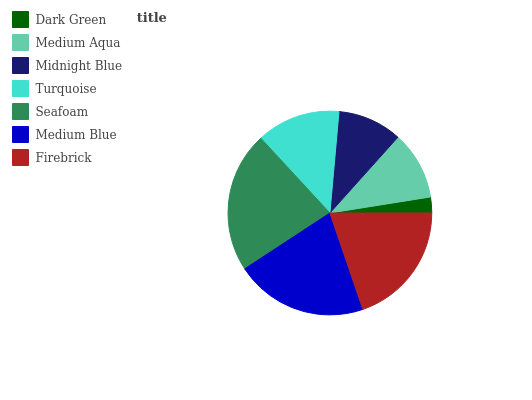Is Dark Green the minimum?
Answer yes or no. Yes. Is Seafoam the maximum?
Answer yes or no. Yes. Is Medium Aqua the minimum?
Answer yes or no. No. Is Medium Aqua the maximum?
Answer yes or no. No. Is Medium Aqua greater than Dark Green?
Answer yes or no. Yes. Is Dark Green less than Medium Aqua?
Answer yes or no. Yes. Is Dark Green greater than Medium Aqua?
Answer yes or no. No. Is Medium Aqua less than Dark Green?
Answer yes or no. No. Is Turquoise the high median?
Answer yes or no. Yes. Is Turquoise the low median?
Answer yes or no. Yes. Is Dark Green the high median?
Answer yes or no. No. Is Seafoam the low median?
Answer yes or no. No. 